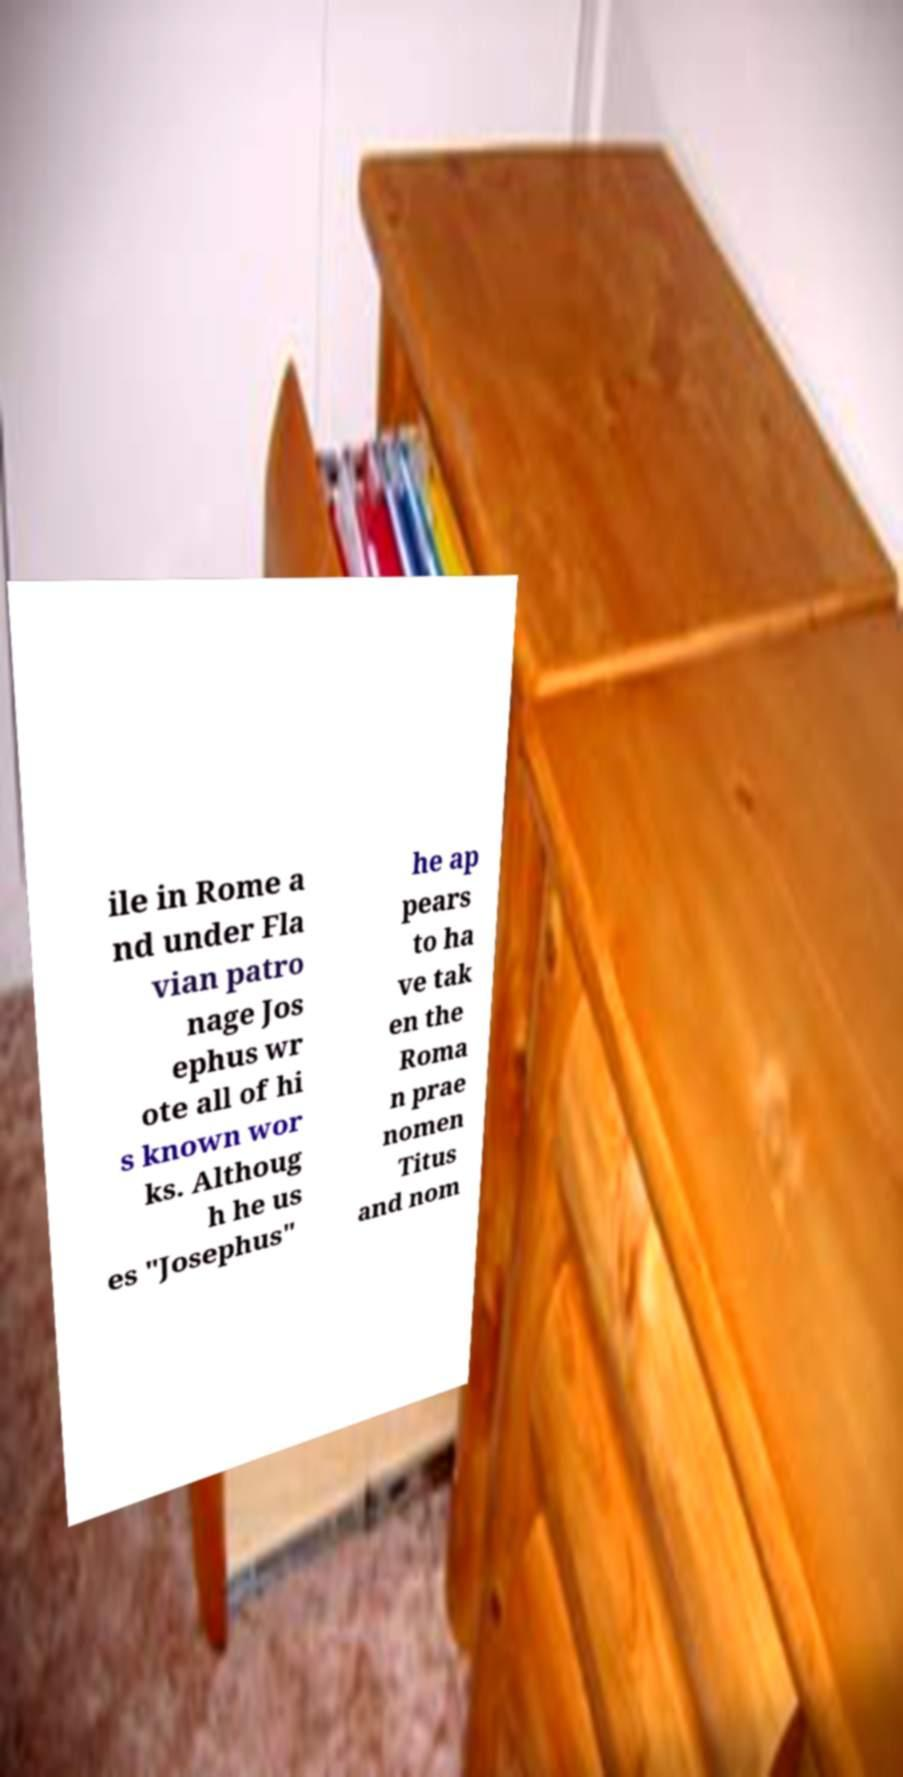Can you read and provide the text displayed in the image?This photo seems to have some interesting text. Can you extract and type it out for me? ile in Rome a nd under Fla vian patro nage Jos ephus wr ote all of hi s known wor ks. Althoug h he us es "Josephus" he ap pears to ha ve tak en the Roma n prae nomen Titus and nom 